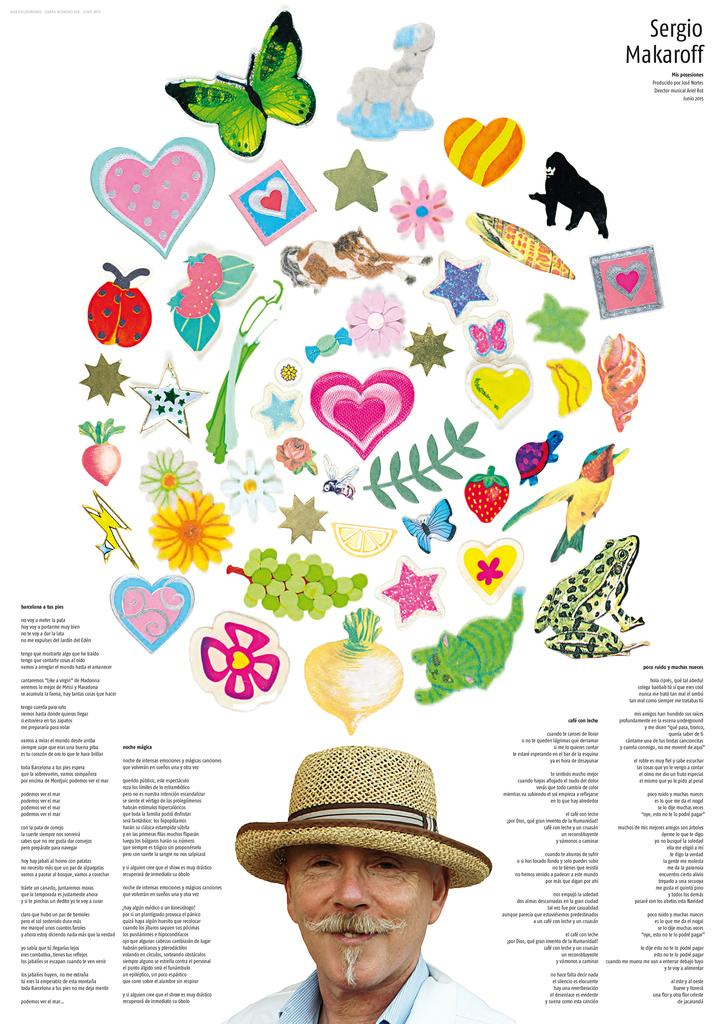What is featured in the image? There is a poster in the image. What can be found on the poster? The poster contains text, a man, pictures of animals, flowers, insects, and fruits. What type of hydrant is depicted in the poster? There is no hydrant present in the poster. What belief system is promoted in the poster? The poster does not promote any specific belief system; it contains pictures of animals, flowers, insects, and fruits, along with text and a man. 